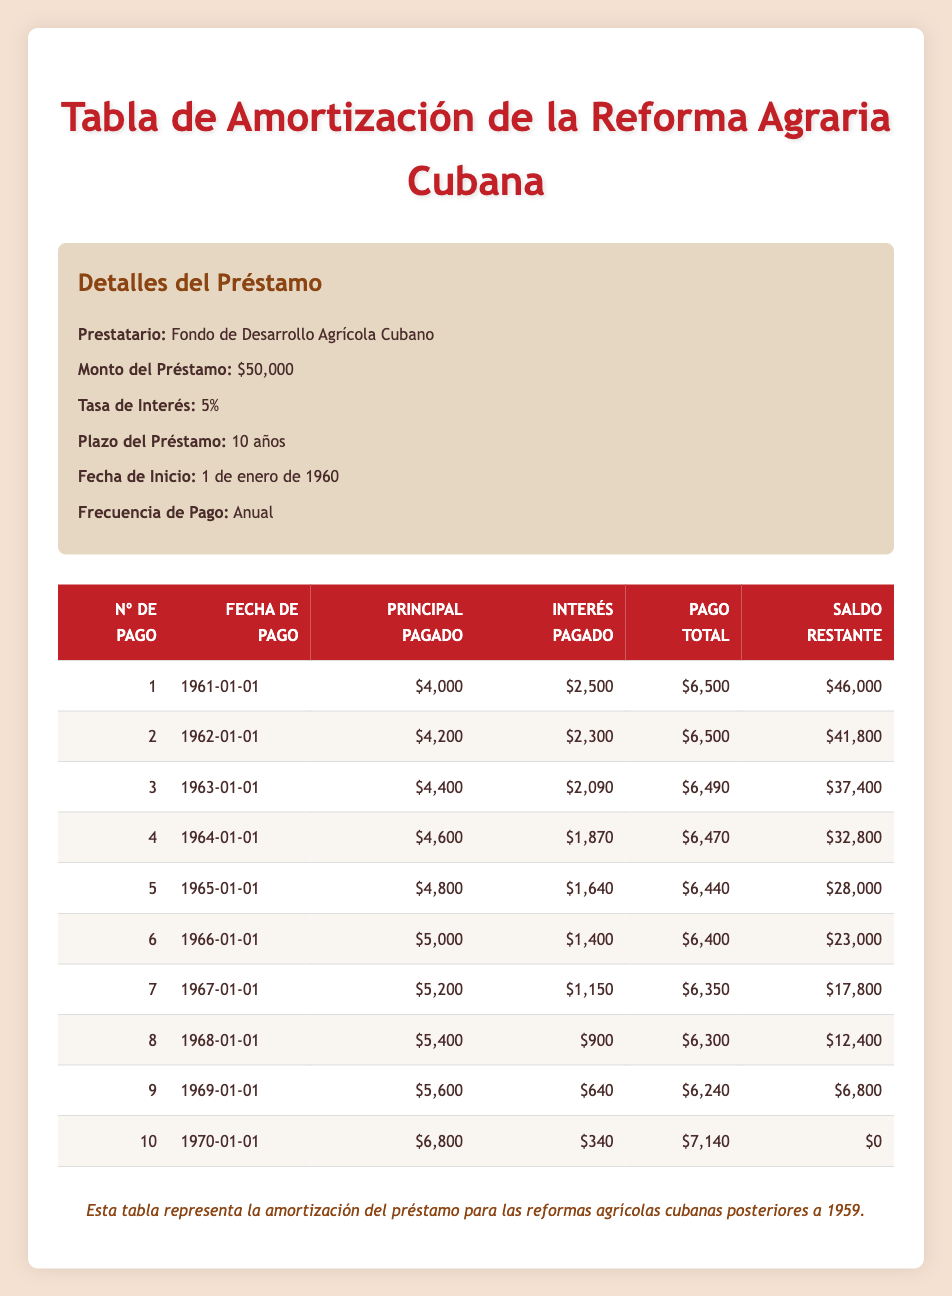¿Cuál es el monto del pago total en el primer año? En la tabla, en la fila que corresponde al primer pago, el monto total pagado es de 6500.
Answer: 6500 ¿Cuánto interés se pagó en el tercer año? En la tabla, se puede ver que para el tercer pago, el interés pagado es de 2090.
Answer: 2090 ¿Hubo un aumento en el monto del principal pagado cada año? Al observar la columna del principal pagado, se puede notar que el principal aumenta progresivamente de 4000 en el primer año a 6800 en el último, confirmando que sí hubo un aumento.
Answer: Sí ¿Cuál es el saldo restante después de 5 años? En la tabla, al final del quinto año, el saldo restante es 28000, que corresponde a la línea del quinto pago.
Answer: 28000 ¿Qué porcentaje del total del préstamo se pagó como interés durante el primer año? En el primer año, se pagó un total de 2500 como interés, de los 50000 del monto original del préstamo, lo que equivale a un porcentaje de (2500/50000)*100 = 5%.
Answer: 5% ¿Cuál fue la suma total de los pagos de principal en los primeros 5 años? Para calcular esta suma, se suman los pagos de principal de los primeros cinco años: 4000 + 4200 + 4400 + 4600 + 4800 = 22000.
Answer: 22000 ¿Qué año tuvo el pago total más bajo? Al observar la columna de pagos totales, se puede ver que el menor pago total es de 6240, que corresponde al noveno año (1969).
Answer: 1969 ¿Cuántos años hubo en que el pago de interés fue menor a 1000? Revisando la columna de interés pagado, se observa que solo en el último año (1970) el interés fue de 340, que es menor a 1000. Por lo tanto, hay 1 año.
Answer: 1 ¿Cuál fue el saldo restante después del séptimo pago? En la tabla, se observa que el saldo restante después del séptimo pago es 17800, que se encuentra en la fila del séptimo año.
Answer: 17800 